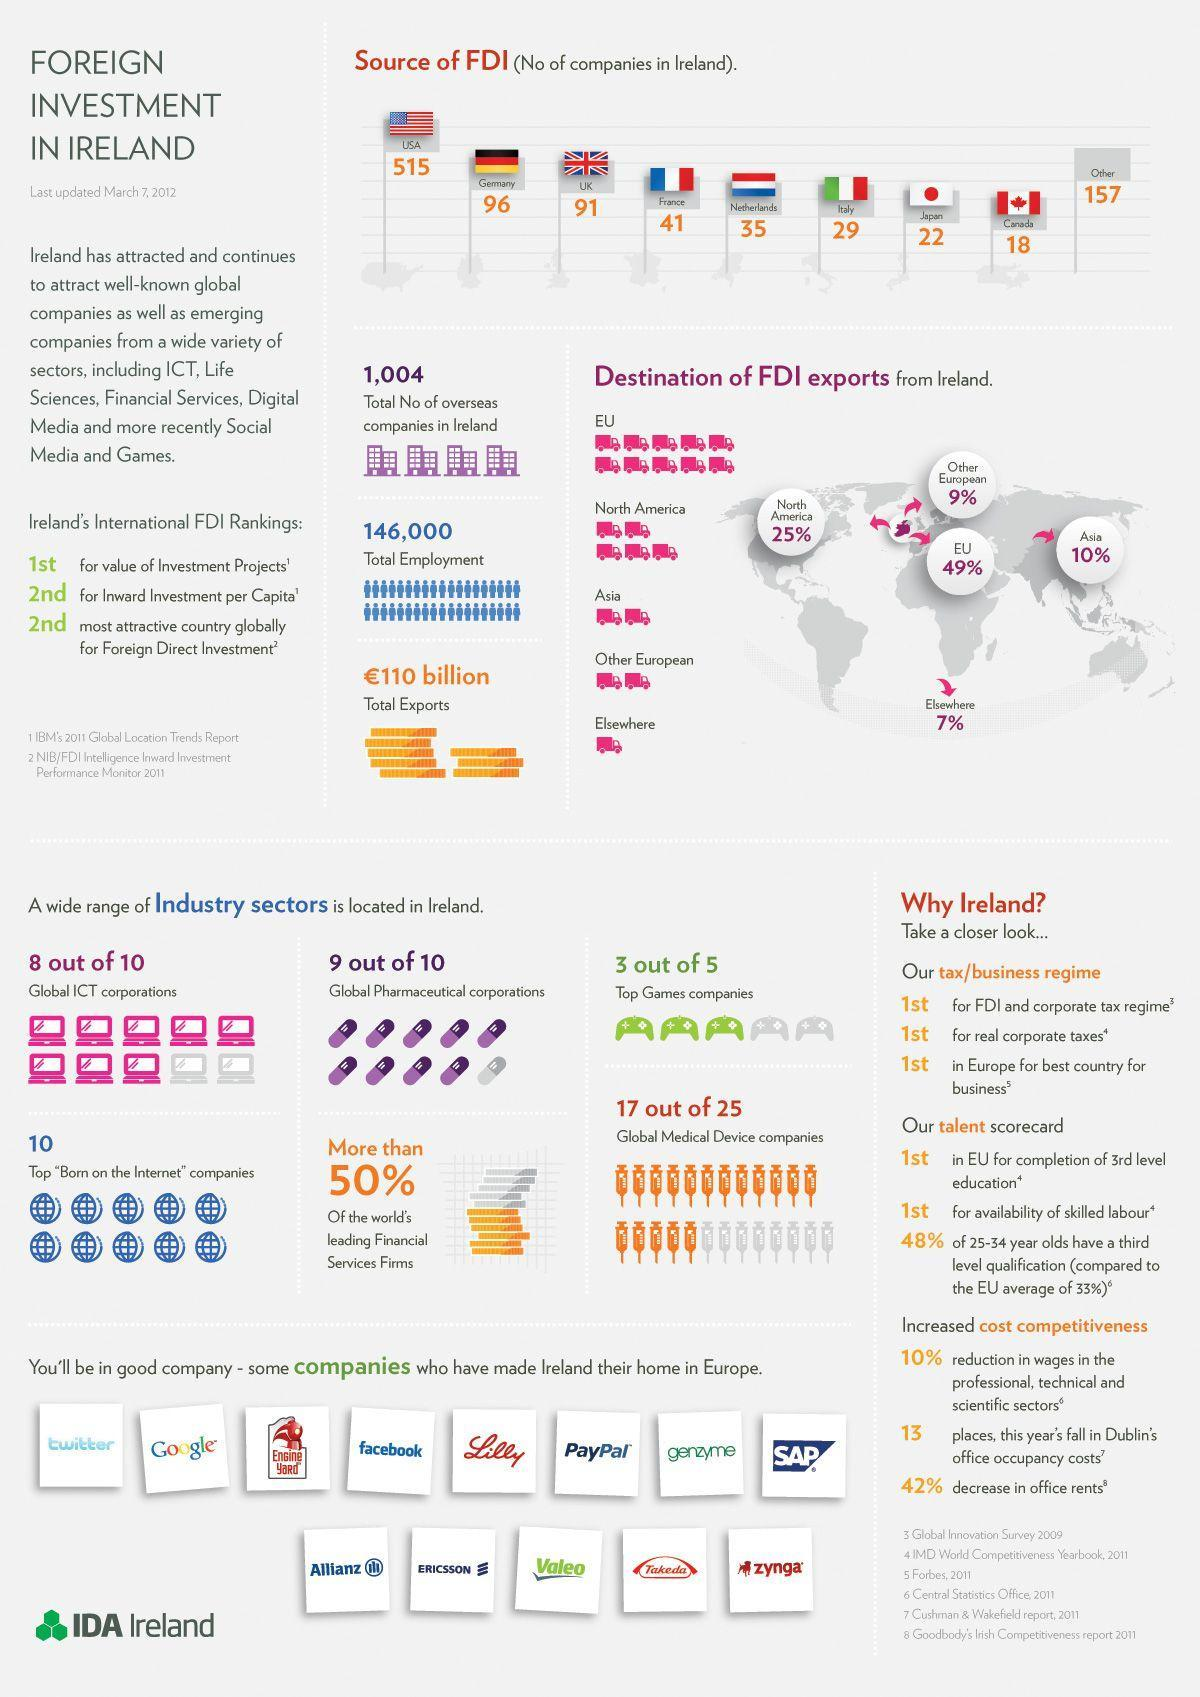What is the Foreign Direct Investment from other countries combined?
Answer the question with a short phrase. 157 Which area has the most FDI Exports from Ireland? EU What is the Foreign Direct Investment from Canada and Japan combined? 40 What is the Foreign Direct Investment from USA and Japan combined? 537 What is the Foreign Direct Investment from Netherlands? 35 Which country is the second in being the most attractive country globally for FDI? Ireland Which country has the second most source of Foreign Direct Investment? Germany Which area has the Second most FDI Exports from Ireland? North America Which country has the most source of Foreign Direct Investment? USA Which country is the second for Inward investment per Capita? Ireland 